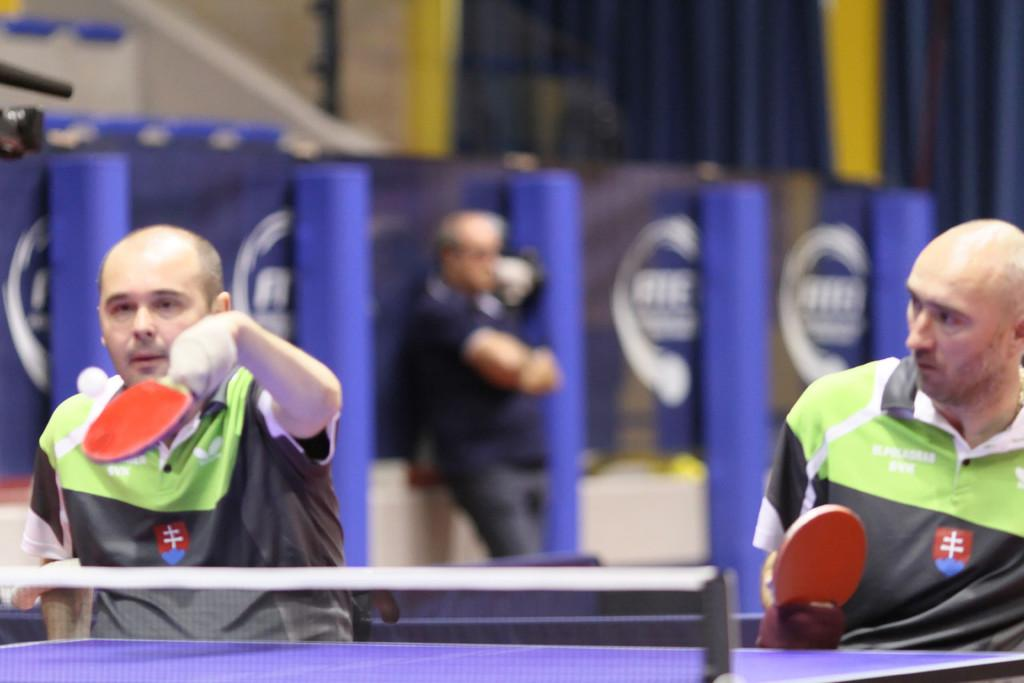How many people are present in the image? There are three people in the image. What activity are the front two people engaged in? The front two people are playing table tennis. What is the position of the person at the back? The person at the back is standing. What type of popcorn is being served at the table tennis scene in the image? There is no popcorn present in the image, and the image does not depict a scene; it simply shows three people, with the front two playing table tennis and the person at the back standing. 